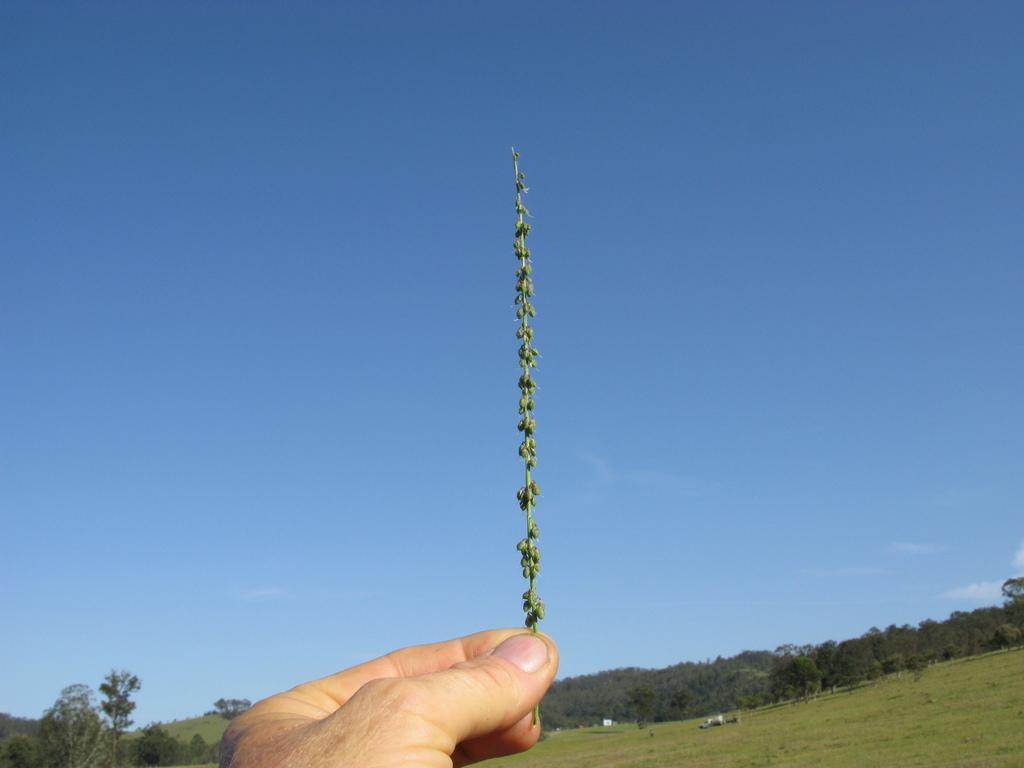Can you describe this image briefly? In this image there is a person holding a small plant, there are trees, white color objects on the grass and some clouds in the sky. 